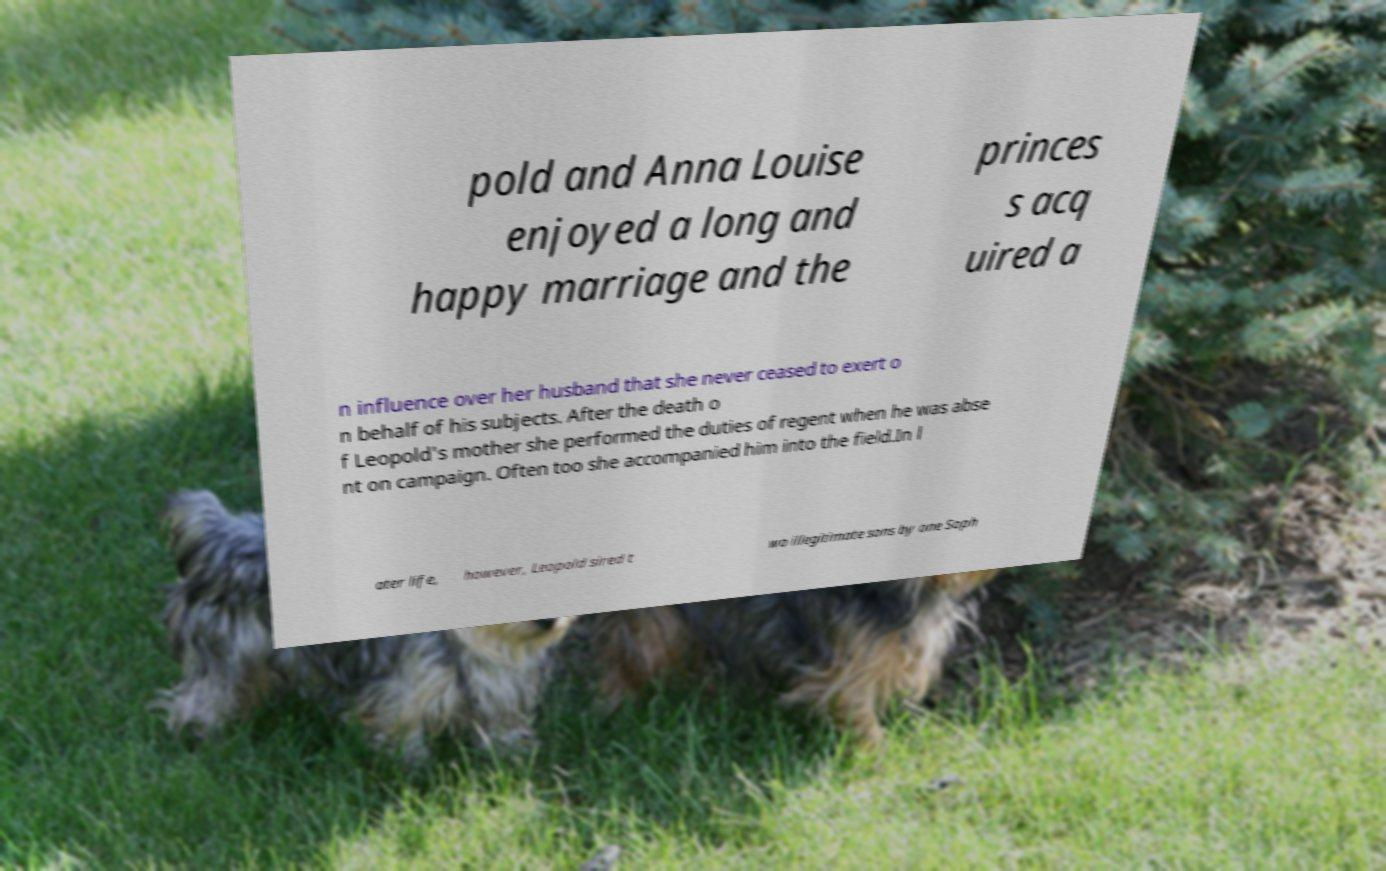Could you extract and type out the text from this image? pold and Anna Louise enjoyed a long and happy marriage and the princes s acq uired a n influence over her husband that she never ceased to exert o n behalf of his subjects. After the death o f Leopold's mother she performed the duties of regent when he was abse nt on campaign. Often too she accompanied him into the field.In l ater life, however, Leopold sired t wo illegitimate sons by one Soph 